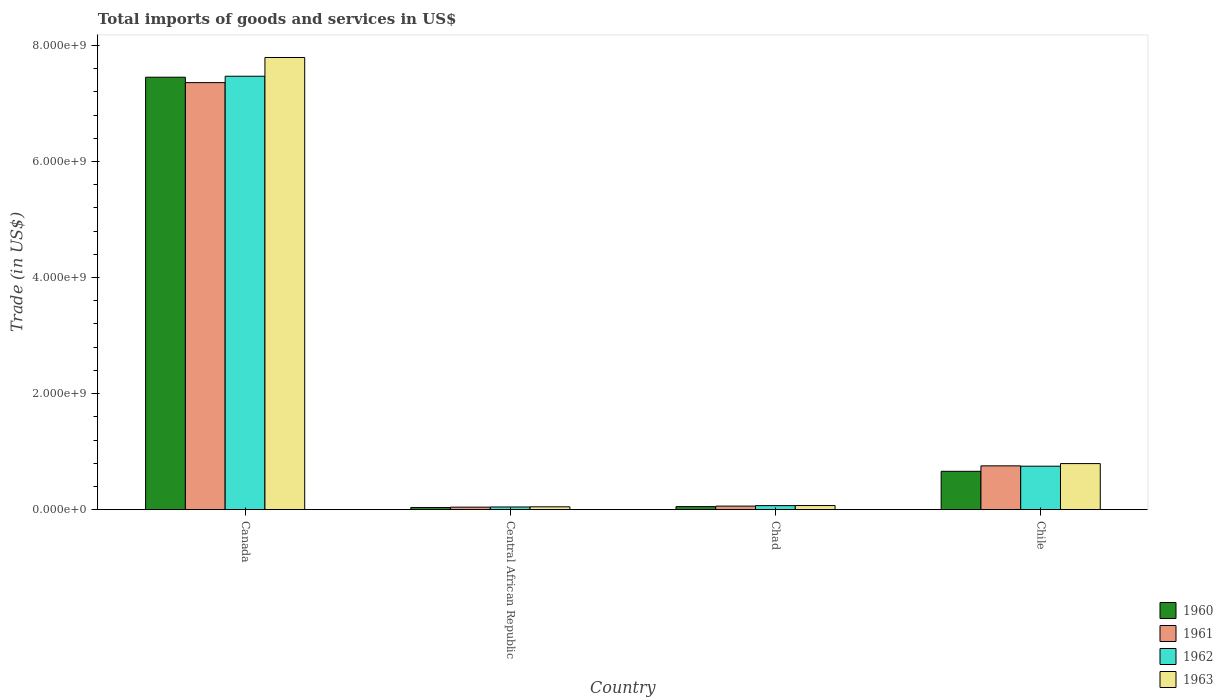How many different coloured bars are there?
Ensure brevity in your answer.  4. How many groups of bars are there?
Your response must be concise. 4. Are the number of bars on each tick of the X-axis equal?
Provide a succinct answer. Yes. How many bars are there on the 1st tick from the left?
Make the answer very short. 4. How many bars are there on the 4th tick from the right?
Offer a terse response. 4. What is the label of the 3rd group of bars from the left?
Your answer should be compact. Chad. What is the total imports of goods and services in 1962 in Chad?
Offer a terse response. 7.02e+07. Across all countries, what is the maximum total imports of goods and services in 1961?
Offer a terse response. 7.36e+09. Across all countries, what is the minimum total imports of goods and services in 1960?
Give a very brief answer. 3.83e+07. In which country was the total imports of goods and services in 1960 minimum?
Ensure brevity in your answer.  Central African Republic. What is the total total imports of goods and services in 1963 in the graph?
Ensure brevity in your answer.  8.71e+09. What is the difference between the total imports of goods and services in 1961 in Canada and that in Chile?
Provide a succinct answer. 6.60e+09. What is the difference between the total imports of goods and services in 1961 in Chile and the total imports of goods and services in 1963 in Chad?
Make the answer very short. 6.84e+08. What is the average total imports of goods and services in 1962 per country?
Give a very brief answer. 2.08e+09. What is the difference between the total imports of goods and services of/in 1961 and total imports of goods and services of/in 1963 in Canada?
Offer a terse response. -4.33e+08. In how many countries, is the total imports of goods and services in 1962 greater than 6000000000 US$?
Provide a succinct answer. 1. What is the ratio of the total imports of goods and services in 1961 in Canada to that in Central African Republic?
Ensure brevity in your answer.  167.13. Is the total imports of goods and services in 1961 in Chad less than that in Chile?
Your answer should be compact. Yes. Is the difference between the total imports of goods and services in 1961 in Canada and Chile greater than the difference between the total imports of goods and services in 1963 in Canada and Chile?
Keep it short and to the point. No. What is the difference between the highest and the second highest total imports of goods and services in 1963?
Keep it short and to the point. 7.00e+09. What is the difference between the highest and the lowest total imports of goods and services in 1963?
Your response must be concise. 7.74e+09. What does the 2nd bar from the left in Central African Republic represents?
Your answer should be very brief. 1961. What does the 4th bar from the right in Chile represents?
Keep it short and to the point. 1960. Are all the bars in the graph horizontal?
Give a very brief answer. No. What is the difference between two consecutive major ticks on the Y-axis?
Keep it short and to the point. 2.00e+09. Does the graph contain any zero values?
Offer a very short reply. No. Does the graph contain grids?
Offer a terse response. No. What is the title of the graph?
Offer a terse response. Total imports of goods and services in US$. What is the label or title of the Y-axis?
Provide a short and direct response. Trade (in US$). What is the Trade (in US$) in 1960 in Canada?
Your response must be concise. 7.45e+09. What is the Trade (in US$) in 1961 in Canada?
Your answer should be compact. 7.36e+09. What is the Trade (in US$) of 1962 in Canada?
Keep it short and to the point. 7.47e+09. What is the Trade (in US$) of 1963 in Canada?
Offer a terse response. 7.79e+09. What is the Trade (in US$) in 1960 in Central African Republic?
Offer a very short reply. 3.83e+07. What is the Trade (in US$) of 1961 in Central African Republic?
Make the answer very short. 4.40e+07. What is the Trade (in US$) of 1962 in Central African Republic?
Keep it short and to the point. 4.69e+07. What is the Trade (in US$) of 1963 in Central African Republic?
Provide a succinct answer. 4.98e+07. What is the Trade (in US$) in 1960 in Chad?
Provide a short and direct response. 5.34e+07. What is the Trade (in US$) of 1961 in Chad?
Provide a short and direct response. 6.20e+07. What is the Trade (in US$) of 1962 in Chad?
Keep it short and to the point. 7.02e+07. What is the Trade (in US$) of 1963 in Chad?
Your response must be concise. 7.14e+07. What is the Trade (in US$) of 1960 in Chile?
Your answer should be compact. 6.62e+08. What is the Trade (in US$) in 1961 in Chile?
Make the answer very short. 7.55e+08. What is the Trade (in US$) of 1962 in Chile?
Your answer should be very brief. 7.50e+08. What is the Trade (in US$) in 1963 in Chile?
Provide a succinct answer. 7.95e+08. Across all countries, what is the maximum Trade (in US$) of 1960?
Keep it short and to the point. 7.45e+09. Across all countries, what is the maximum Trade (in US$) of 1961?
Offer a terse response. 7.36e+09. Across all countries, what is the maximum Trade (in US$) in 1962?
Your response must be concise. 7.47e+09. Across all countries, what is the maximum Trade (in US$) of 1963?
Your response must be concise. 7.79e+09. Across all countries, what is the minimum Trade (in US$) in 1960?
Give a very brief answer. 3.83e+07. Across all countries, what is the minimum Trade (in US$) of 1961?
Ensure brevity in your answer.  4.40e+07. Across all countries, what is the minimum Trade (in US$) in 1962?
Give a very brief answer. 4.69e+07. Across all countries, what is the minimum Trade (in US$) in 1963?
Your response must be concise. 4.98e+07. What is the total Trade (in US$) in 1960 in the graph?
Give a very brief answer. 8.21e+09. What is the total Trade (in US$) in 1961 in the graph?
Make the answer very short. 8.22e+09. What is the total Trade (in US$) of 1962 in the graph?
Offer a very short reply. 8.34e+09. What is the total Trade (in US$) in 1963 in the graph?
Provide a succinct answer. 8.71e+09. What is the difference between the Trade (in US$) in 1960 in Canada and that in Central African Republic?
Your answer should be compact. 7.41e+09. What is the difference between the Trade (in US$) of 1961 in Canada and that in Central African Republic?
Provide a short and direct response. 7.32e+09. What is the difference between the Trade (in US$) of 1962 in Canada and that in Central African Republic?
Ensure brevity in your answer.  7.42e+09. What is the difference between the Trade (in US$) in 1963 in Canada and that in Central African Republic?
Offer a very short reply. 7.74e+09. What is the difference between the Trade (in US$) of 1960 in Canada and that in Chad?
Offer a very short reply. 7.40e+09. What is the difference between the Trade (in US$) of 1961 in Canada and that in Chad?
Offer a very short reply. 7.30e+09. What is the difference between the Trade (in US$) of 1962 in Canada and that in Chad?
Offer a terse response. 7.40e+09. What is the difference between the Trade (in US$) in 1963 in Canada and that in Chad?
Provide a succinct answer. 7.72e+09. What is the difference between the Trade (in US$) in 1960 in Canada and that in Chile?
Offer a very short reply. 6.79e+09. What is the difference between the Trade (in US$) of 1961 in Canada and that in Chile?
Provide a short and direct response. 6.60e+09. What is the difference between the Trade (in US$) of 1962 in Canada and that in Chile?
Your answer should be compact. 6.72e+09. What is the difference between the Trade (in US$) in 1963 in Canada and that in Chile?
Your answer should be compact. 7.00e+09. What is the difference between the Trade (in US$) of 1960 in Central African Republic and that in Chad?
Offer a very short reply. -1.51e+07. What is the difference between the Trade (in US$) in 1961 in Central African Republic and that in Chad?
Ensure brevity in your answer.  -1.79e+07. What is the difference between the Trade (in US$) in 1962 in Central African Republic and that in Chad?
Make the answer very short. -2.33e+07. What is the difference between the Trade (in US$) of 1963 in Central African Republic and that in Chad?
Your response must be concise. -2.16e+07. What is the difference between the Trade (in US$) in 1960 in Central African Republic and that in Chile?
Your answer should be compact. -6.23e+08. What is the difference between the Trade (in US$) in 1961 in Central African Republic and that in Chile?
Your response must be concise. -7.11e+08. What is the difference between the Trade (in US$) in 1962 in Central African Republic and that in Chile?
Offer a very short reply. -7.03e+08. What is the difference between the Trade (in US$) of 1963 in Central African Republic and that in Chile?
Offer a terse response. -7.45e+08. What is the difference between the Trade (in US$) of 1960 in Chad and that in Chile?
Offer a terse response. -6.08e+08. What is the difference between the Trade (in US$) in 1961 in Chad and that in Chile?
Offer a very short reply. -6.93e+08. What is the difference between the Trade (in US$) in 1962 in Chad and that in Chile?
Keep it short and to the point. -6.80e+08. What is the difference between the Trade (in US$) of 1963 in Chad and that in Chile?
Offer a terse response. -7.23e+08. What is the difference between the Trade (in US$) of 1960 in Canada and the Trade (in US$) of 1961 in Central African Republic?
Ensure brevity in your answer.  7.41e+09. What is the difference between the Trade (in US$) of 1960 in Canada and the Trade (in US$) of 1962 in Central African Republic?
Keep it short and to the point. 7.41e+09. What is the difference between the Trade (in US$) of 1960 in Canada and the Trade (in US$) of 1963 in Central African Republic?
Make the answer very short. 7.40e+09. What is the difference between the Trade (in US$) of 1961 in Canada and the Trade (in US$) of 1962 in Central African Republic?
Give a very brief answer. 7.31e+09. What is the difference between the Trade (in US$) of 1961 in Canada and the Trade (in US$) of 1963 in Central African Republic?
Your response must be concise. 7.31e+09. What is the difference between the Trade (in US$) in 1962 in Canada and the Trade (in US$) in 1963 in Central African Republic?
Provide a succinct answer. 7.42e+09. What is the difference between the Trade (in US$) of 1960 in Canada and the Trade (in US$) of 1961 in Chad?
Your answer should be compact. 7.39e+09. What is the difference between the Trade (in US$) in 1960 in Canada and the Trade (in US$) in 1962 in Chad?
Your answer should be compact. 7.38e+09. What is the difference between the Trade (in US$) in 1960 in Canada and the Trade (in US$) in 1963 in Chad?
Your answer should be compact. 7.38e+09. What is the difference between the Trade (in US$) of 1961 in Canada and the Trade (in US$) of 1962 in Chad?
Your answer should be compact. 7.29e+09. What is the difference between the Trade (in US$) in 1961 in Canada and the Trade (in US$) in 1963 in Chad?
Your answer should be compact. 7.29e+09. What is the difference between the Trade (in US$) of 1962 in Canada and the Trade (in US$) of 1963 in Chad?
Your answer should be compact. 7.40e+09. What is the difference between the Trade (in US$) in 1960 in Canada and the Trade (in US$) in 1961 in Chile?
Your answer should be compact. 6.70e+09. What is the difference between the Trade (in US$) in 1960 in Canada and the Trade (in US$) in 1962 in Chile?
Provide a short and direct response. 6.70e+09. What is the difference between the Trade (in US$) of 1960 in Canada and the Trade (in US$) of 1963 in Chile?
Your answer should be very brief. 6.66e+09. What is the difference between the Trade (in US$) of 1961 in Canada and the Trade (in US$) of 1962 in Chile?
Give a very brief answer. 6.61e+09. What is the difference between the Trade (in US$) in 1961 in Canada and the Trade (in US$) in 1963 in Chile?
Your answer should be compact. 6.56e+09. What is the difference between the Trade (in US$) in 1962 in Canada and the Trade (in US$) in 1963 in Chile?
Give a very brief answer. 6.67e+09. What is the difference between the Trade (in US$) in 1960 in Central African Republic and the Trade (in US$) in 1961 in Chad?
Your answer should be very brief. -2.36e+07. What is the difference between the Trade (in US$) of 1960 in Central African Republic and the Trade (in US$) of 1962 in Chad?
Make the answer very short. -3.19e+07. What is the difference between the Trade (in US$) of 1960 in Central African Republic and the Trade (in US$) of 1963 in Chad?
Your response must be concise. -3.31e+07. What is the difference between the Trade (in US$) of 1961 in Central African Republic and the Trade (in US$) of 1962 in Chad?
Offer a terse response. -2.62e+07. What is the difference between the Trade (in US$) of 1961 in Central African Republic and the Trade (in US$) of 1963 in Chad?
Provide a short and direct response. -2.74e+07. What is the difference between the Trade (in US$) of 1962 in Central African Republic and the Trade (in US$) of 1963 in Chad?
Keep it short and to the point. -2.45e+07. What is the difference between the Trade (in US$) in 1960 in Central African Republic and the Trade (in US$) in 1961 in Chile?
Make the answer very short. -7.17e+08. What is the difference between the Trade (in US$) in 1960 in Central African Republic and the Trade (in US$) in 1962 in Chile?
Offer a terse response. -7.11e+08. What is the difference between the Trade (in US$) of 1960 in Central African Republic and the Trade (in US$) of 1963 in Chile?
Your answer should be compact. -7.56e+08. What is the difference between the Trade (in US$) of 1961 in Central African Republic and the Trade (in US$) of 1962 in Chile?
Offer a very short reply. -7.06e+08. What is the difference between the Trade (in US$) of 1961 in Central African Republic and the Trade (in US$) of 1963 in Chile?
Keep it short and to the point. -7.51e+08. What is the difference between the Trade (in US$) of 1962 in Central African Republic and the Trade (in US$) of 1963 in Chile?
Offer a very short reply. -7.48e+08. What is the difference between the Trade (in US$) of 1960 in Chad and the Trade (in US$) of 1961 in Chile?
Ensure brevity in your answer.  -7.02e+08. What is the difference between the Trade (in US$) of 1960 in Chad and the Trade (in US$) of 1962 in Chile?
Offer a very short reply. -6.96e+08. What is the difference between the Trade (in US$) of 1960 in Chad and the Trade (in US$) of 1963 in Chile?
Make the answer very short. -7.41e+08. What is the difference between the Trade (in US$) of 1961 in Chad and the Trade (in US$) of 1962 in Chile?
Ensure brevity in your answer.  -6.88e+08. What is the difference between the Trade (in US$) in 1961 in Chad and the Trade (in US$) in 1963 in Chile?
Keep it short and to the point. -7.33e+08. What is the difference between the Trade (in US$) in 1962 in Chad and the Trade (in US$) in 1963 in Chile?
Provide a succinct answer. -7.25e+08. What is the average Trade (in US$) of 1960 per country?
Your response must be concise. 2.05e+09. What is the average Trade (in US$) of 1961 per country?
Provide a succinct answer. 2.06e+09. What is the average Trade (in US$) of 1962 per country?
Give a very brief answer. 2.08e+09. What is the average Trade (in US$) in 1963 per country?
Give a very brief answer. 2.18e+09. What is the difference between the Trade (in US$) of 1960 and Trade (in US$) of 1961 in Canada?
Ensure brevity in your answer.  9.32e+07. What is the difference between the Trade (in US$) in 1960 and Trade (in US$) in 1962 in Canada?
Your response must be concise. -1.67e+07. What is the difference between the Trade (in US$) in 1960 and Trade (in US$) in 1963 in Canada?
Your response must be concise. -3.40e+08. What is the difference between the Trade (in US$) in 1961 and Trade (in US$) in 1962 in Canada?
Offer a terse response. -1.10e+08. What is the difference between the Trade (in US$) in 1961 and Trade (in US$) in 1963 in Canada?
Ensure brevity in your answer.  -4.33e+08. What is the difference between the Trade (in US$) in 1962 and Trade (in US$) in 1963 in Canada?
Make the answer very short. -3.23e+08. What is the difference between the Trade (in US$) in 1960 and Trade (in US$) in 1961 in Central African Republic?
Give a very brief answer. -5.70e+06. What is the difference between the Trade (in US$) of 1960 and Trade (in US$) of 1962 in Central African Republic?
Offer a terse response. -8.60e+06. What is the difference between the Trade (in US$) in 1960 and Trade (in US$) in 1963 in Central African Republic?
Your answer should be very brief. -1.15e+07. What is the difference between the Trade (in US$) of 1961 and Trade (in US$) of 1962 in Central African Republic?
Offer a very short reply. -2.90e+06. What is the difference between the Trade (in US$) in 1961 and Trade (in US$) in 1963 in Central African Republic?
Ensure brevity in your answer.  -5.76e+06. What is the difference between the Trade (in US$) of 1962 and Trade (in US$) of 1963 in Central African Republic?
Keep it short and to the point. -2.86e+06. What is the difference between the Trade (in US$) in 1960 and Trade (in US$) in 1961 in Chad?
Provide a succinct answer. -8.55e+06. What is the difference between the Trade (in US$) in 1960 and Trade (in US$) in 1962 in Chad?
Provide a succinct answer. -1.68e+07. What is the difference between the Trade (in US$) in 1960 and Trade (in US$) in 1963 in Chad?
Make the answer very short. -1.80e+07. What is the difference between the Trade (in US$) in 1961 and Trade (in US$) in 1962 in Chad?
Make the answer very short. -8.23e+06. What is the difference between the Trade (in US$) of 1961 and Trade (in US$) of 1963 in Chad?
Provide a succinct answer. -9.45e+06. What is the difference between the Trade (in US$) of 1962 and Trade (in US$) of 1963 in Chad?
Your response must be concise. -1.22e+06. What is the difference between the Trade (in US$) in 1960 and Trade (in US$) in 1961 in Chile?
Provide a short and direct response. -9.38e+07. What is the difference between the Trade (in US$) of 1960 and Trade (in US$) of 1962 in Chile?
Offer a terse response. -8.81e+07. What is the difference between the Trade (in US$) of 1960 and Trade (in US$) of 1963 in Chile?
Offer a terse response. -1.33e+08. What is the difference between the Trade (in US$) of 1961 and Trade (in US$) of 1962 in Chile?
Give a very brief answer. 5.71e+06. What is the difference between the Trade (in US$) of 1961 and Trade (in US$) of 1963 in Chile?
Keep it short and to the point. -3.92e+07. What is the difference between the Trade (in US$) in 1962 and Trade (in US$) in 1963 in Chile?
Your answer should be compact. -4.50e+07. What is the ratio of the Trade (in US$) in 1960 in Canada to that in Central African Republic?
Offer a terse response. 194.4. What is the ratio of the Trade (in US$) in 1961 in Canada to that in Central African Republic?
Give a very brief answer. 167.13. What is the ratio of the Trade (in US$) in 1962 in Canada to that in Central African Republic?
Your answer should be compact. 159.14. What is the ratio of the Trade (in US$) of 1963 in Canada to that in Central African Republic?
Your response must be concise. 156.5. What is the ratio of the Trade (in US$) of 1960 in Canada to that in Chad?
Provide a succinct answer. 139.49. What is the ratio of the Trade (in US$) of 1961 in Canada to that in Chad?
Your answer should be compact. 118.75. What is the ratio of the Trade (in US$) of 1962 in Canada to that in Chad?
Your answer should be compact. 106.4. What is the ratio of the Trade (in US$) of 1963 in Canada to that in Chad?
Your answer should be compact. 109.1. What is the ratio of the Trade (in US$) in 1960 in Canada to that in Chile?
Your answer should be very brief. 11.26. What is the ratio of the Trade (in US$) of 1961 in Canada to that in Chile?
Give a very brief answer. 9.74. What is the ratio of the Trade (in US$) of 1962 in Canada to that in Chile?
Keep it short and to the point. 9.96. What is the ratio of the Trade (in US$) in 1963 in Canada to that in Chile?
Provide a short and direct response. 9.81. What is the ratio of the Trade (in US$) in 1960 in Central African Republic to that in Chad?
Provide a short and direct response. 0.72. What is the ratio of the Trade (in US$) of 1961 in Central African Republic to that in Chad?
Provide a short and direct response. 0.71. What is the ratio of the Trade (in US$) of 1962 in Central African Republic to that in Chad?
Ensure brevity in your answer.  0.67. What is the ratio of the Trade (in US$) in 1963 in Central African Republic to that in Chad?
Provide a succinct answer. 0.7. What is the ratio of the Trade (in US$) of 1960 in Central African Republic to that in Chile?
Your response must be concise. 0.06. What is the ratio of the Trade (in US$) of 1961 in Central African Republic to that in Chile?
Offer a terse response. 0.06. What is the ratio of the Trade (in US$) of 1962 in Central African Republic to that in Chile?
Ensure brevity in your answer.  0.06. What is the ratio of the Trade (in US$) of 1963 in Central African Republic to that in Chile?
Make the answer very short. 0.06. What is the ratio of the Trade (in US$) of 1960 in Chad to that in Chile?
Your answer should be compact. 0.08. What is the ratio of the Trade (in US$) in 1961 in Chad to that in Chile?
Your answer should be compact. 0.08. What is the ratio of the Trade (in US$) in 1962 in Chad to that in Chile?
Offer a terse response. 0.09. What is the ratio of the Trade (in US$) in 1963 in Chad to that in Chile?
Provide a short and direct response. 0.09. What is the difference between the highest and the second highest Trade (in US$) of 1960?
Keep it short and to the point. 6.79e+09. What is the difference between the highest and the second highest Trade (in US$) in 1961?
Make the answer very short. 6.60e+09. What is the difference between the highest and the second highest Trade (in US$) in 1962?
Your answer should be compact. 6.72e+09. What is the difference between the highest and the second highest Trade (in US$) of 1963?
Your answer should be very brief. 7.00e+09. What is the difference between the highest and the lowest Trade (in US$) of 1960?
Ensure brevity in your answer.  7.41e+09. What is the difference between the highest and the lowest Trade (in US$) of 1961?
Your answer should be very brief. 7.32e+09. What is the difference between the highest and the lowest Trade (in US$) of 1962?
Give a very brief answer. 7.42e+09. What is the difference between the highest and the lowest Trade (in US$) of 1963?
Make the answer very short. 7.74e+09. 